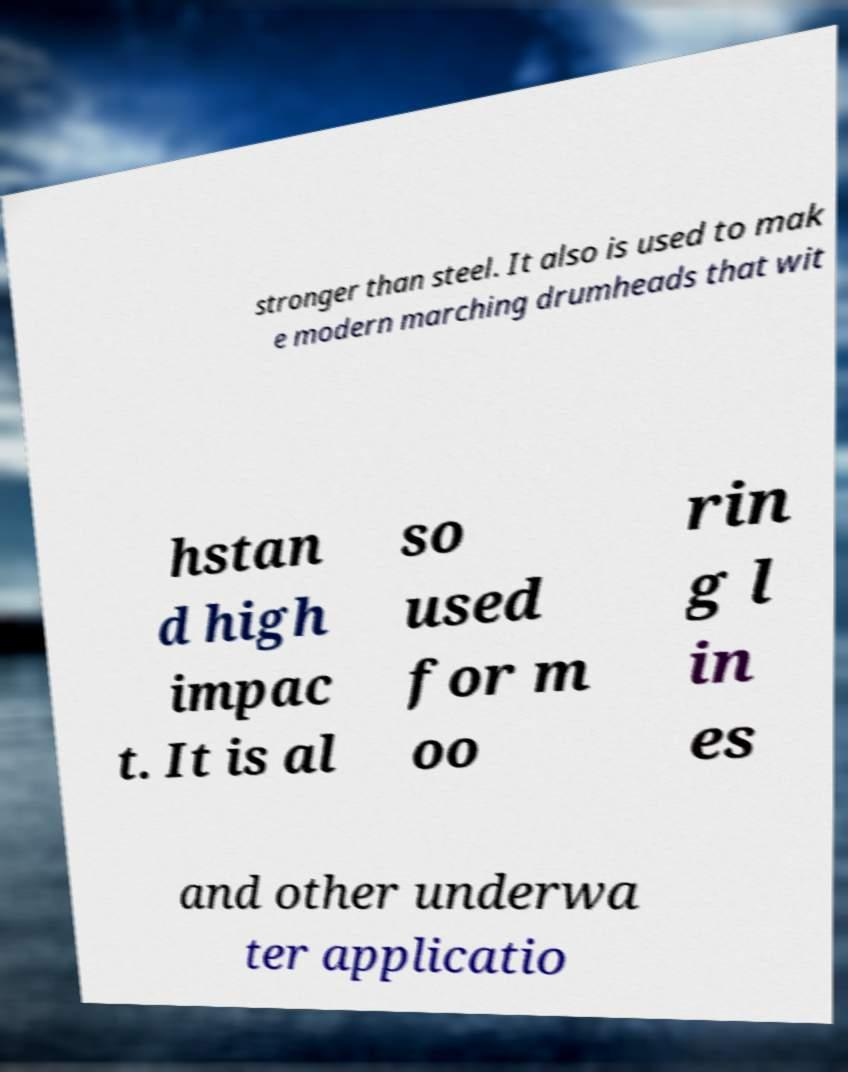There's text embedded in this image that I need extracted. Can you transcribe it verbatim? stronger than steel. It also is used to mak e modern marching drumheads that wit hstan d high impac t. It is al so used for m oo rin g l in es and other underwa ter applicatio 